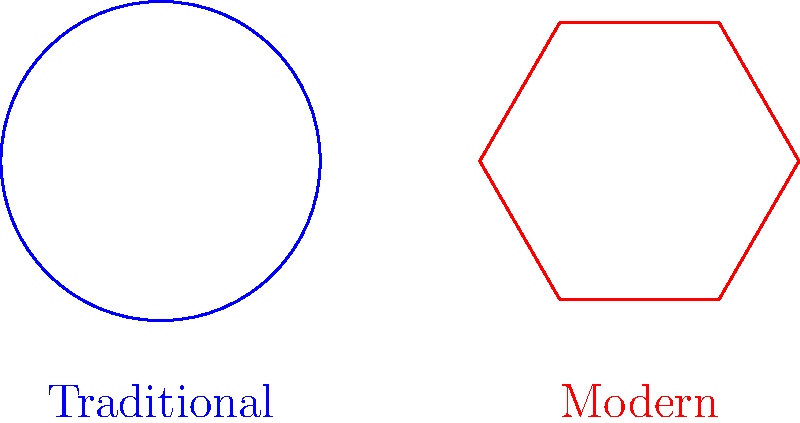The image shows two shapes representing fish feed pellets: a circular traditional pellet and a hexagonal modern pellet. If both pellets have the same area, which shape would have a greater surface area, potentially affecting nutrient absorption? To determine which shape has a greater surface area given the same area, we need to compare the perimeter-to-area ratios:

1. For a circle (traditional pellet):
   - Area: $A_c = \pi r^2$
   - Perimeter: $P_c = 2\pi r$
   - Ratio: $\frac{P_c}{A_c} = \frac{2\pi r}{\pi r^2} = \frac{2}{r}$

2. For a regular hexagon (modern pellet):
   - Area: $A_h = \frac{3\sqrt{3}}{2}s^2$, where $s$ is the side length
   - Perimeter: $P_h = 6s$
   - Ratio: $\frac{P_h}{A_h} = \frac{6s}{\frac{3\sqrt{3}}{2}s^2} = \frac{4}{\sqrt{3}s}$

3. To compare, we need to express the hexagon's ratio in terms of $r$:
   - Equating areas: $\pi r^2 = \frac{3\sqrt{3}}{2}s^2$
   - Solving for $s$: $s = r\sqrt{\frac{2\pi}{3\sqrt{3}}}$

4. Substituting this into the hexagon's ratio:
   $\frac{P_h}{A_h} = \frac{4}{\sqrt{3}r\sqrt{\frac{2\pi}{3\sqrt{3}}}} \approx \frac{2.103}{r}$

5. Comparing ratios:
   - Circle: $\frac{2}{r}$
   - Hexagon: $\frac{2.103}{r}$

The hexagon (modern pellet) has a slightly higher perimeter-to-area ratio, indicating a greater surface area for the same overall area.
Answer: The modern hexagonal pellet has a greater surface area. 